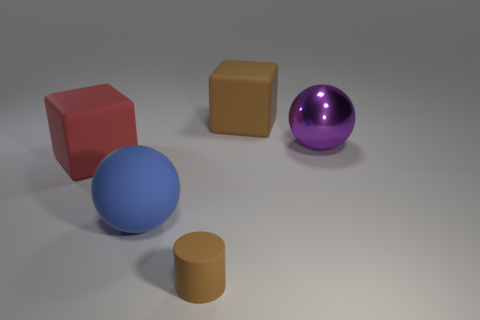Add 3 balls. How many objects exist? 8 Add 1 purple balls. How many purple balls are left? 2 Add 2 tiny brown matte cubes. How many tiny brown matte cubes exist? 2 Subtract 0 yellow spheres. How many objects are left? 5 Subtract all cubes. How many objects are left? 3 Subtract all brown blocks. Subtract all brown cylinders. How many blocks are left? 1 Subtract all green rubber cylinders. Subtract all blue balls. How many objects are left? 4 